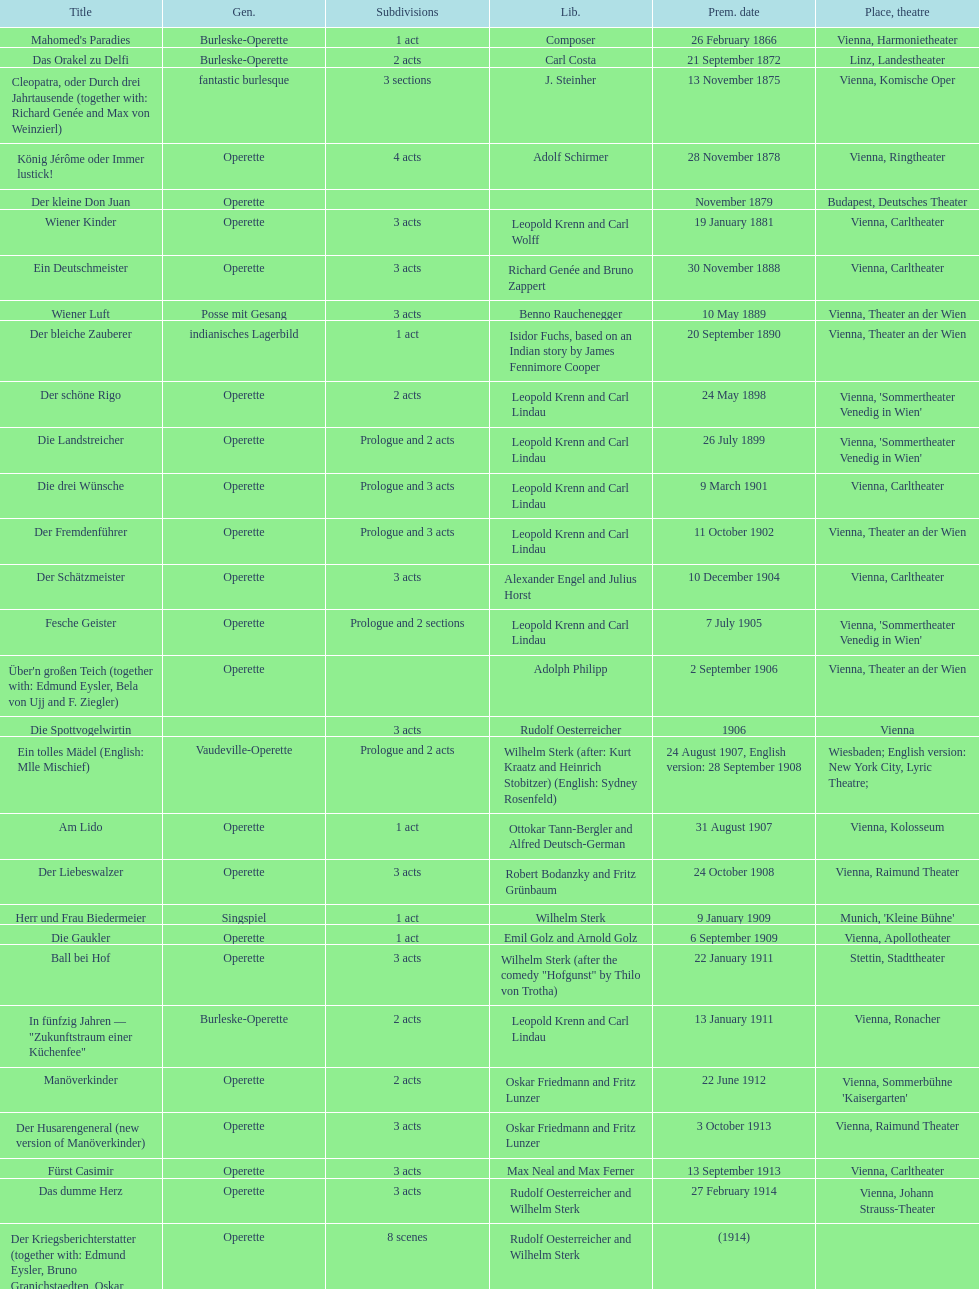Which genre is featured the most in this chart? Operette. 